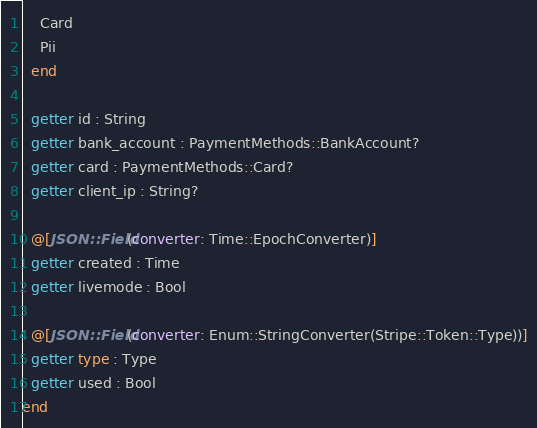Convert code to text. <code><loc_0><loc_0><loc_500><loc_500><_Crystal_>    Card
    Pii
  end

  getter id : String
  getter bank_account : PaymentMethods::BankAccount?
  getter card : PaymentMethods::Card?
  getter client_ip : String?

  @[JSON::Field(converter: Time::EpochConverter)]
  getter created : Time
  getter livemode : Bool

  @[JSON::Field(converter: Enum::StringConverter(Stripe::Token::Type))]
  getter type : Type
  getter used : Bool
end
</code> 